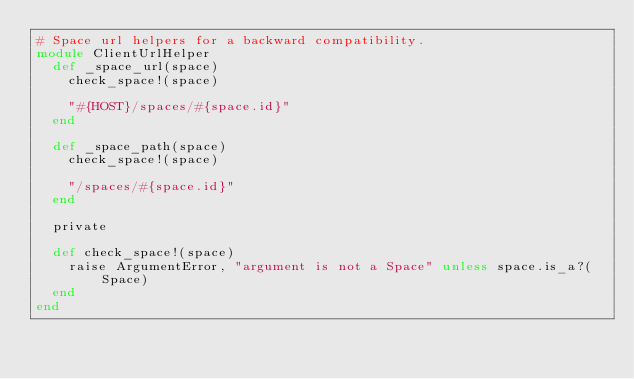<code> <loc_0><loc_0><loc_500><loc_500><_Ruby_># Space url helpers for a backward compatibility.
module ClientUrlHelper
  def _space_url(space)
    check_space!(space)

    "#{HOST}/spaces/#{space.id}"
  end

  def _space_path(space)
    check_space!(space)

    "/spaces/#{space.id}"
  end

  private

  def check_space!(space)
    raise ArgumentError, "argument is not a Space" unless space.is_a?(Space)
  end
end
</code> 